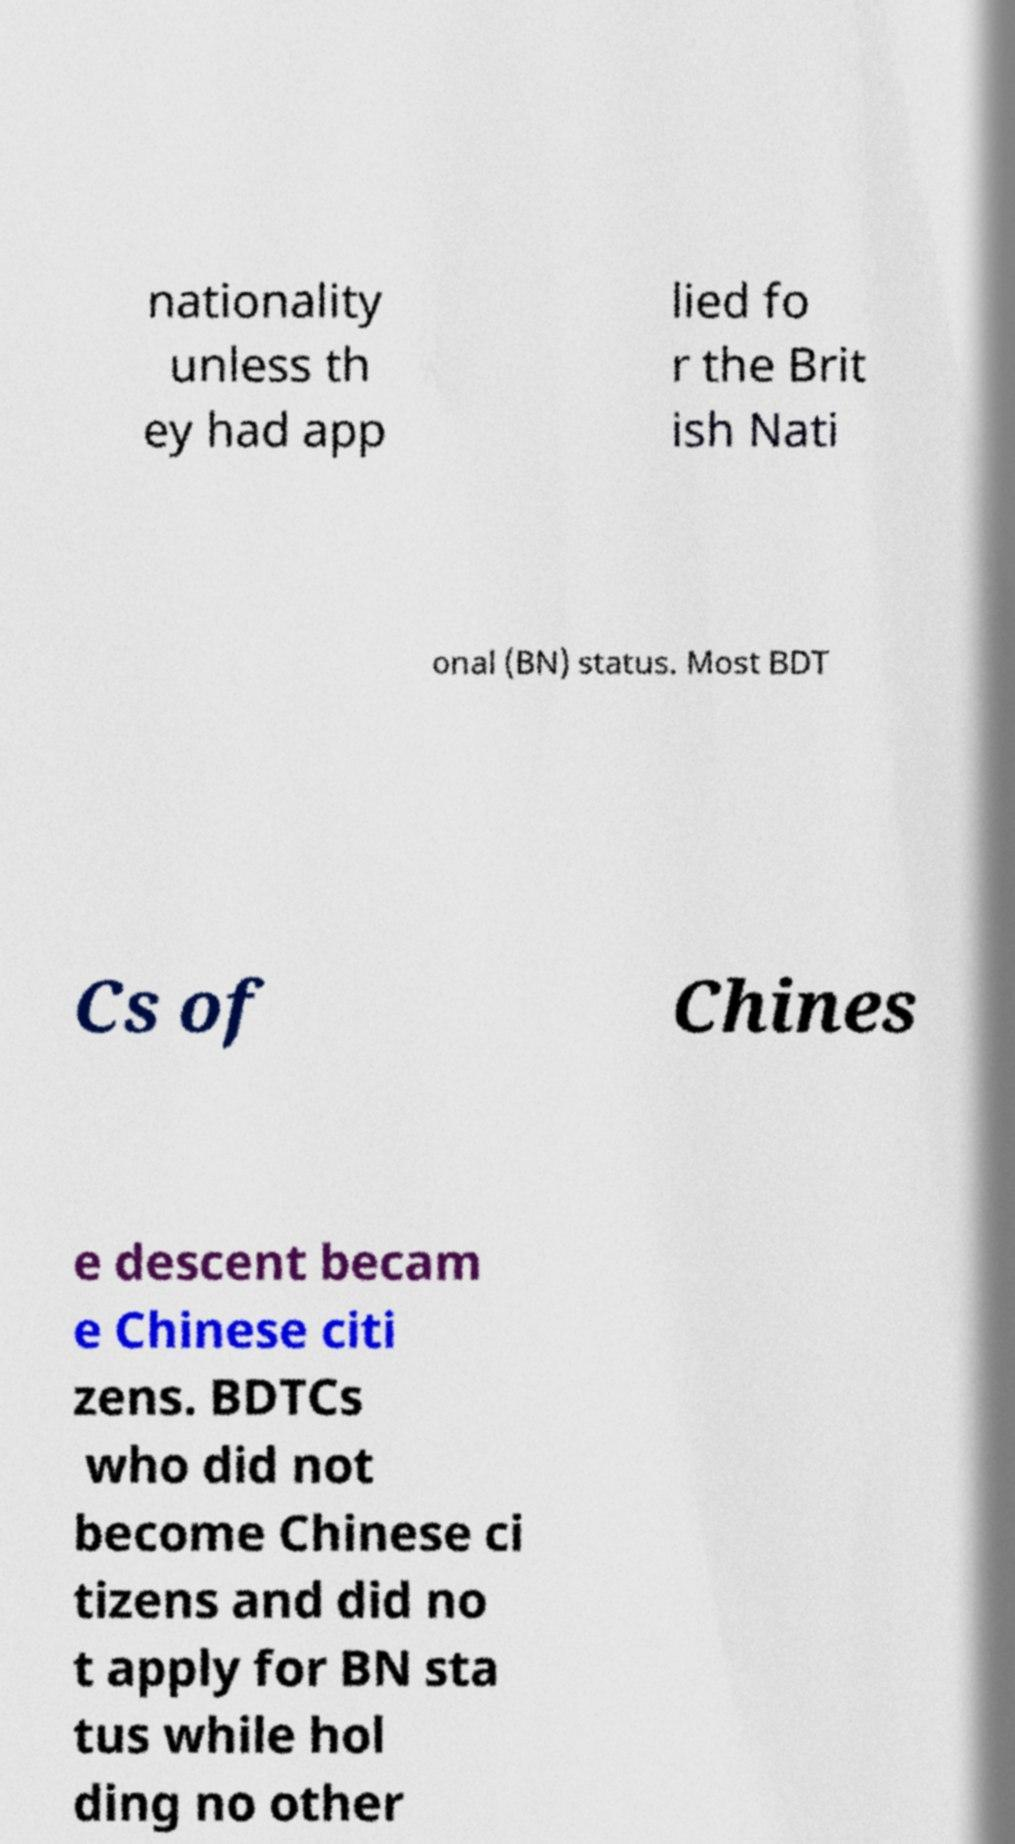Can you read and provide the text displayed in the image?This photo seems to have some interesting text. Can you extract and type it out for me? nationality unless th ey had app lied fo r the Brit ish Nati onal (BN) status. Most BDT Cs of Chines e descent becam e Chinese citi zens. BDTCs who did not become Chinese ci tizens and did no t apply for BN sta tus while hol ding no other 